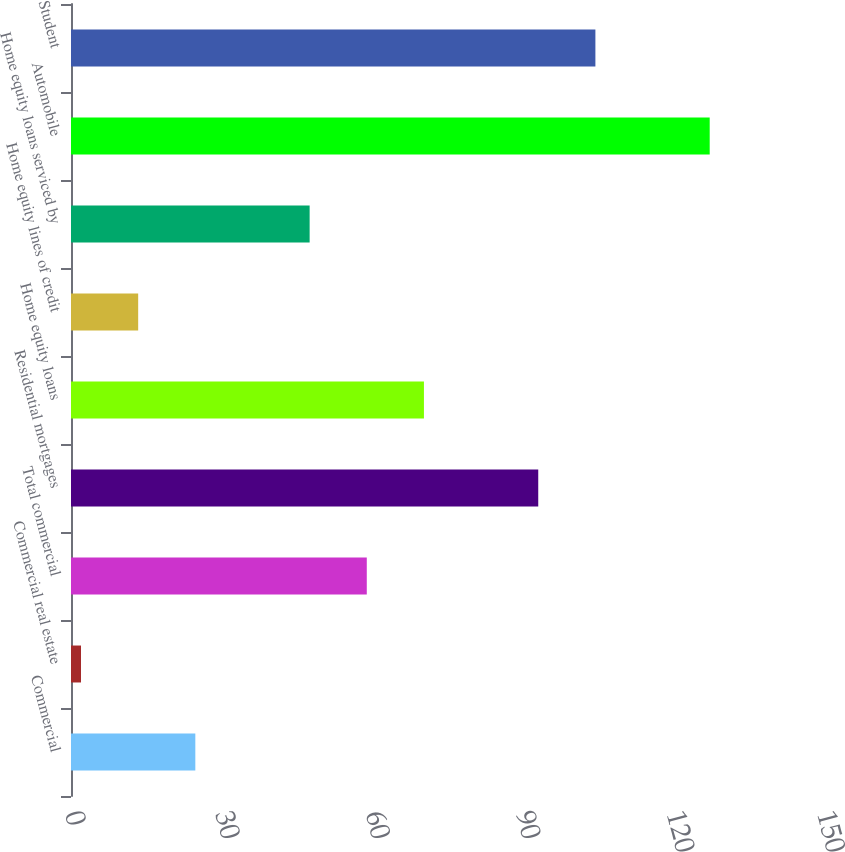Convert chart to OTSL. <chart><loc_0><loc_0><loc_500><loc_500><bar_chart><fcel>Commercial<fcel>Commercial real estate<fcel>Total commercial<fcel>Residential mortgages<fcel>Home equity loans<fcel>Home equity lines of credit<fcel>Home equity loans serviced by<fcel>Automobile<fcel>Student<nl><fcel>24.8<fcel>2<fcel>59<fcel>93.2<fcel>70.4<fcel>13.4<fcel>47.6<fcel>127.4<fcel>104.6<nl></chart> 